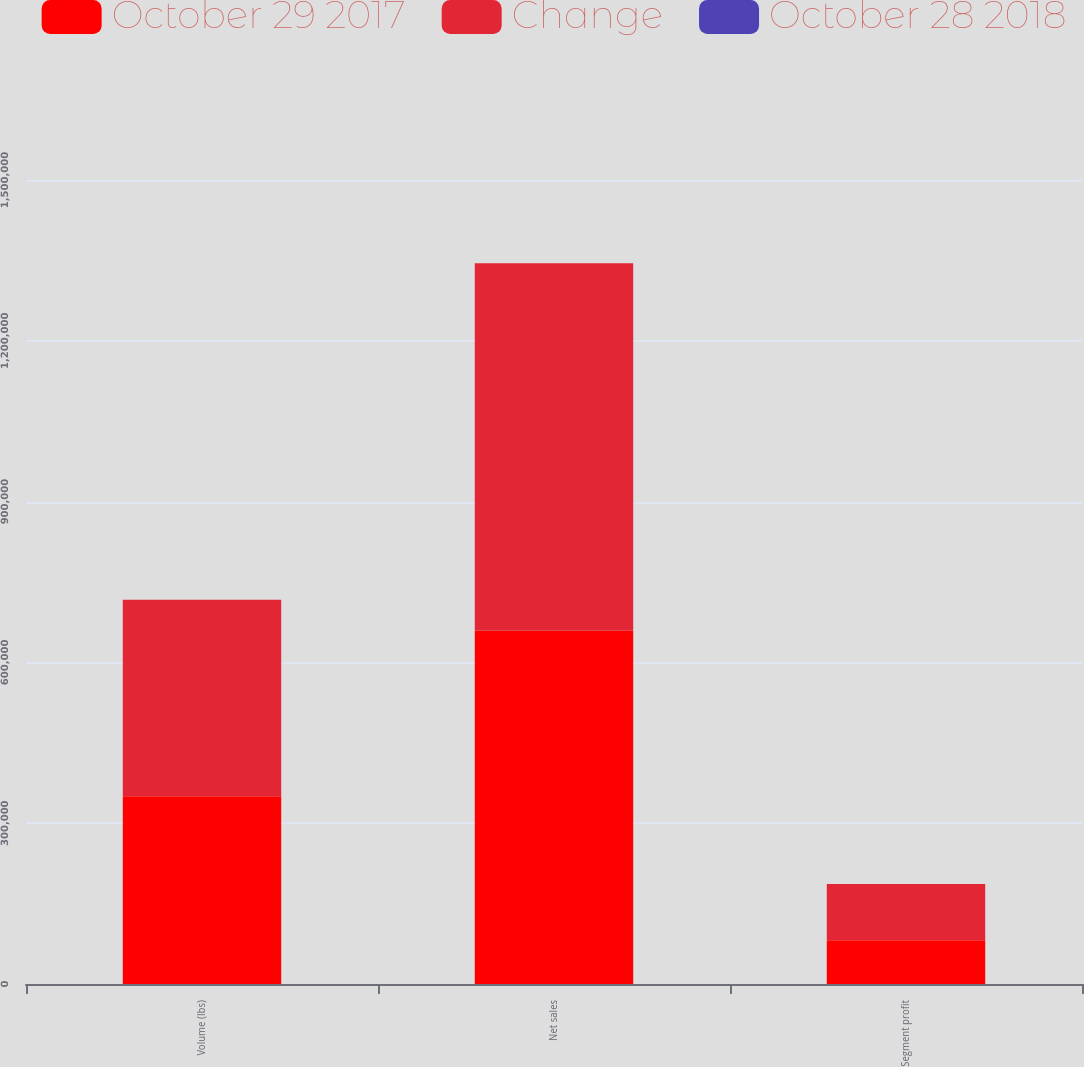<chart> <loc_0><loc_0><loc_500><loc_500><stacked_bar_chart><ecel><fcel>Volume (lbs)<fcel>Net sales<fcel>Segment profit<nl><fcel>October 29 2017<fcel>350399<fcel>658845<fcel>81582<nl><fcel>Change<fcel>366485<fcel>685961<fcel>104848<nl><fcel>October 28 2018<fcel>4.4<fcel>4<fcel>22.2<nl></chart> 